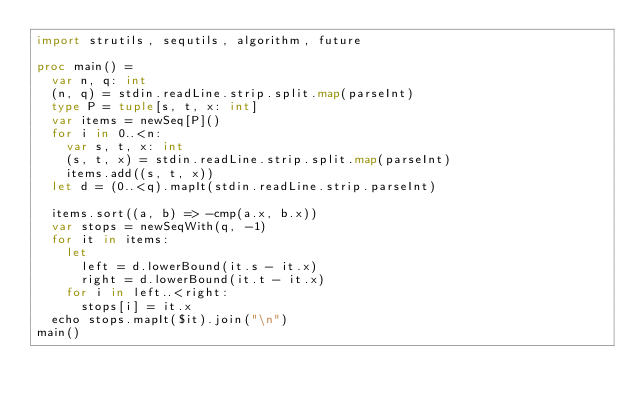Convert code to text. <code><loc_0><loc_0><loc_500><loc_500><_Nim_>import strutils, sequtils, algorithm, future

proc main() =
  var n, q: int
  (n, q) = stdin.readLine.strip.split.map(parseInt)
  type P = tuple[s, t, x: int]
  var items = newSeq[P]()
  for i in 0..<n:
    var s, t, x: int
    (s, t, x) = stdin.readLine.strip.split.map(parseInt)
    items.add((s, t, x))
  let d = (0..<q).mapIt(stdin.readLine.strip.parseInt)

  items.sort((a, b) => -cmp(a.x, b.x))
  var stops = newSeqWith(q, -1)
  for it in items:
    let
      left = d.lowerBound(it.s - it.x)
      right = d.lowerBound(it.t - it.x)
    for i in left..<right:
      stops[i] = it.x
  echo stops.mapIt($it).join("\n")
main()
</code> 